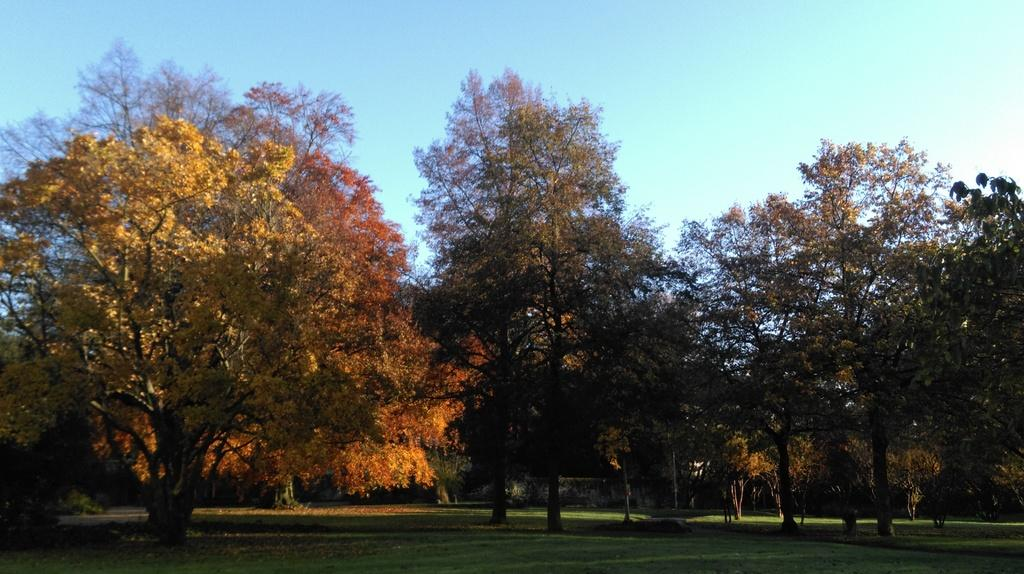What type of trees can be seen in the image? There are autumn trees in the image. What is the ground covered with beneath the trees? The trees are on green grass. What color is the sky in the image? The sky is blue. Can you hear the man coughing in the image? There is no man or any sound mentioned in the image, so it is not possible to determine if someone is coughing. 